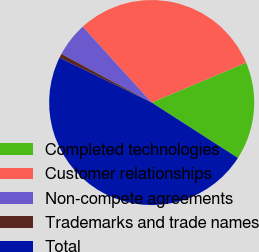Convert chart. <chart><loc_0><loc_0><loc_500><loc_500><pie_chart><fcel>Completed technologies<fcel>Customer relationships<fcel>Non-compete agreements<fcel>Trademarks and trade names<fcel>Total<nl><fcel>15.46%<fcel>30.38%<fcel>5.4%<fcel>0.65%<fcel>48.12%<nl></chart> 